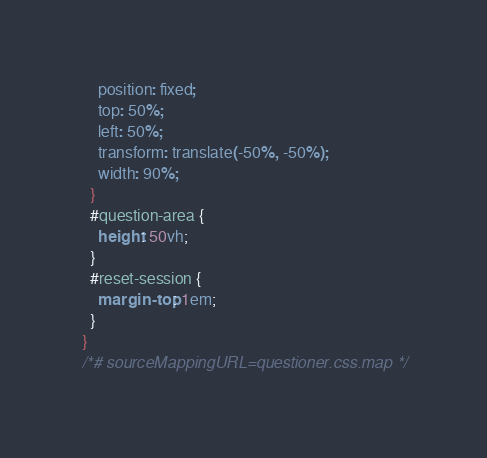Convert code to text. <code><loc_0><loc_0><loc_500><loc_500><_CSS_>    position: fixed;
    top: 50%;
    left: 50%;
    transform: translate(-50%, -50%);
    width: 90%;
  }
  #question-area {
    height: 50vh;
  }
  #reset-session {
    margin-top: 1em;
  }
}
/*# sourceMappingURL=questioner.css.map */</code> 